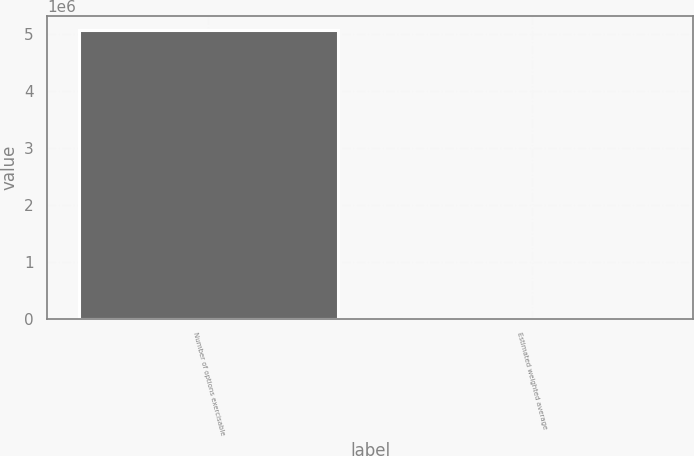Convert chart. <chart><loc_0><loc_0><loc_500><loc_500><bar_chart><fcel>Number of options exercisable<fcel>Estimated weighted average<nl><fcel>5.07598e+06<fcel>19.71<nl></chart> 